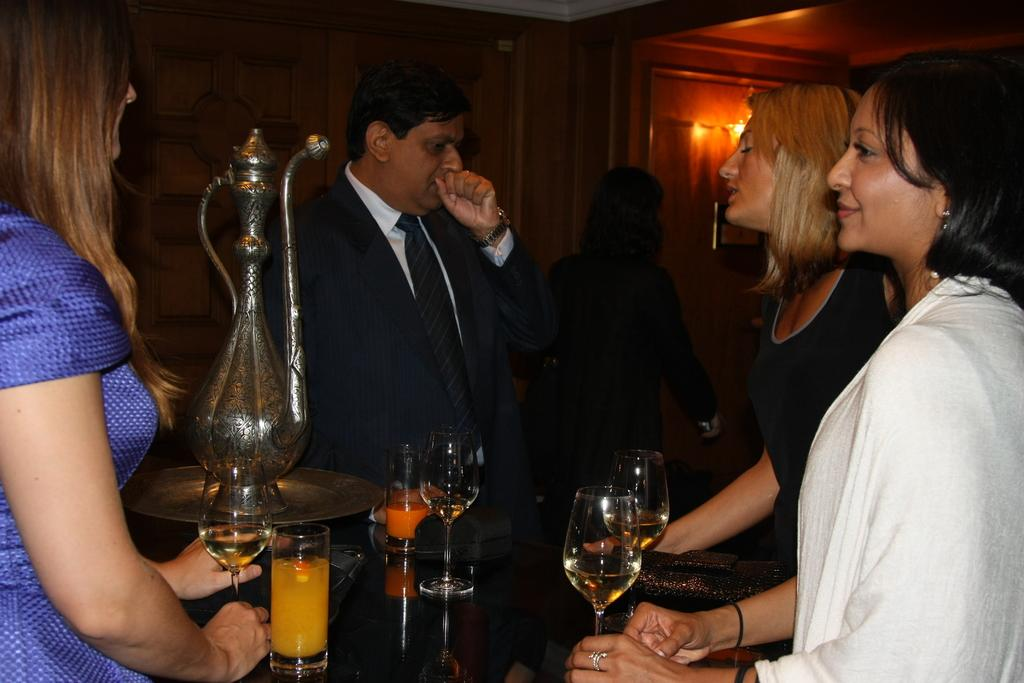What can be seen in the image? There are people standing in the image, including a woman. What objects are on the table? There are glasses and a jug on the table. What can be seen in the background or surroundings? There are lights visible in the image. What type of competition is taking place in the image? There is no competition present in the image; it simply shows people standing and objects on a table. What reason do the people have for standing in the image? The image does not provide any information about the reason for the people standing; they could be waiting, socializing, or for any other purpose. 